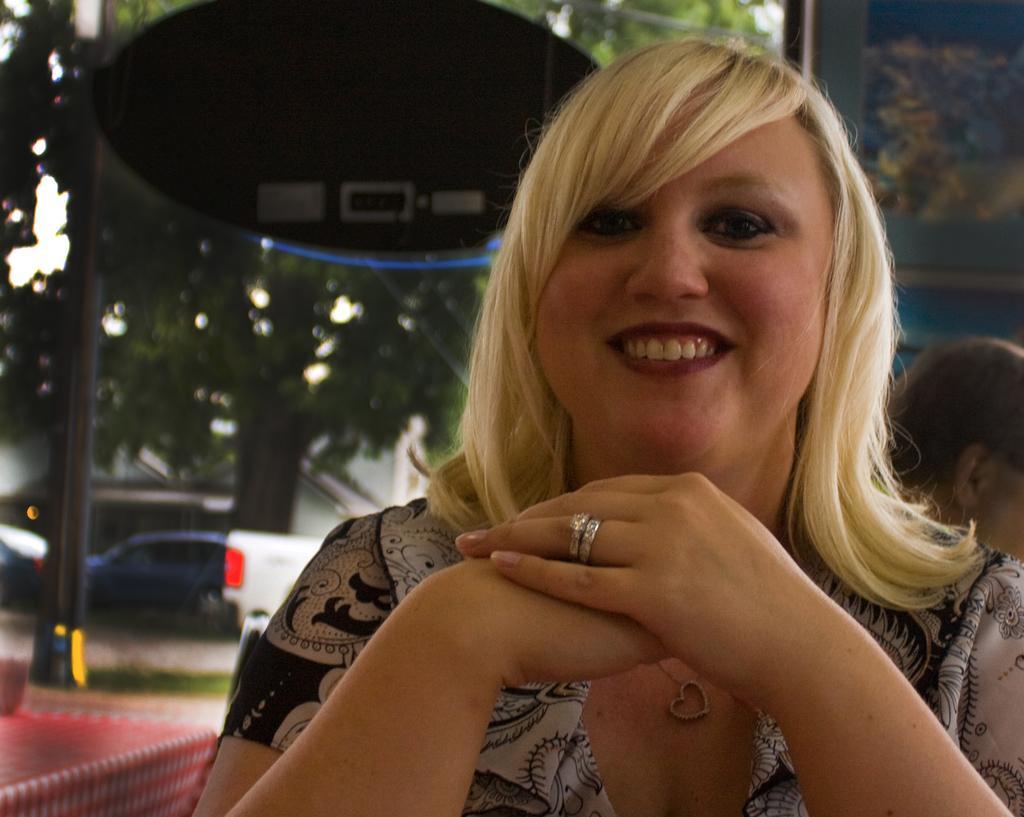Please provide a concise description of this image. This picture is clicked inside. On the right there is a woman smiling and seems to be sitting on the chair. On the left there is a red color table. In the background we can see a person and trees, pole and some vehicles seems to be parked on the ground. 